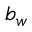Convert formula to latex. <formula><loc_0><loc_0><loc_500><loc_500>b _ { w }</formula> 